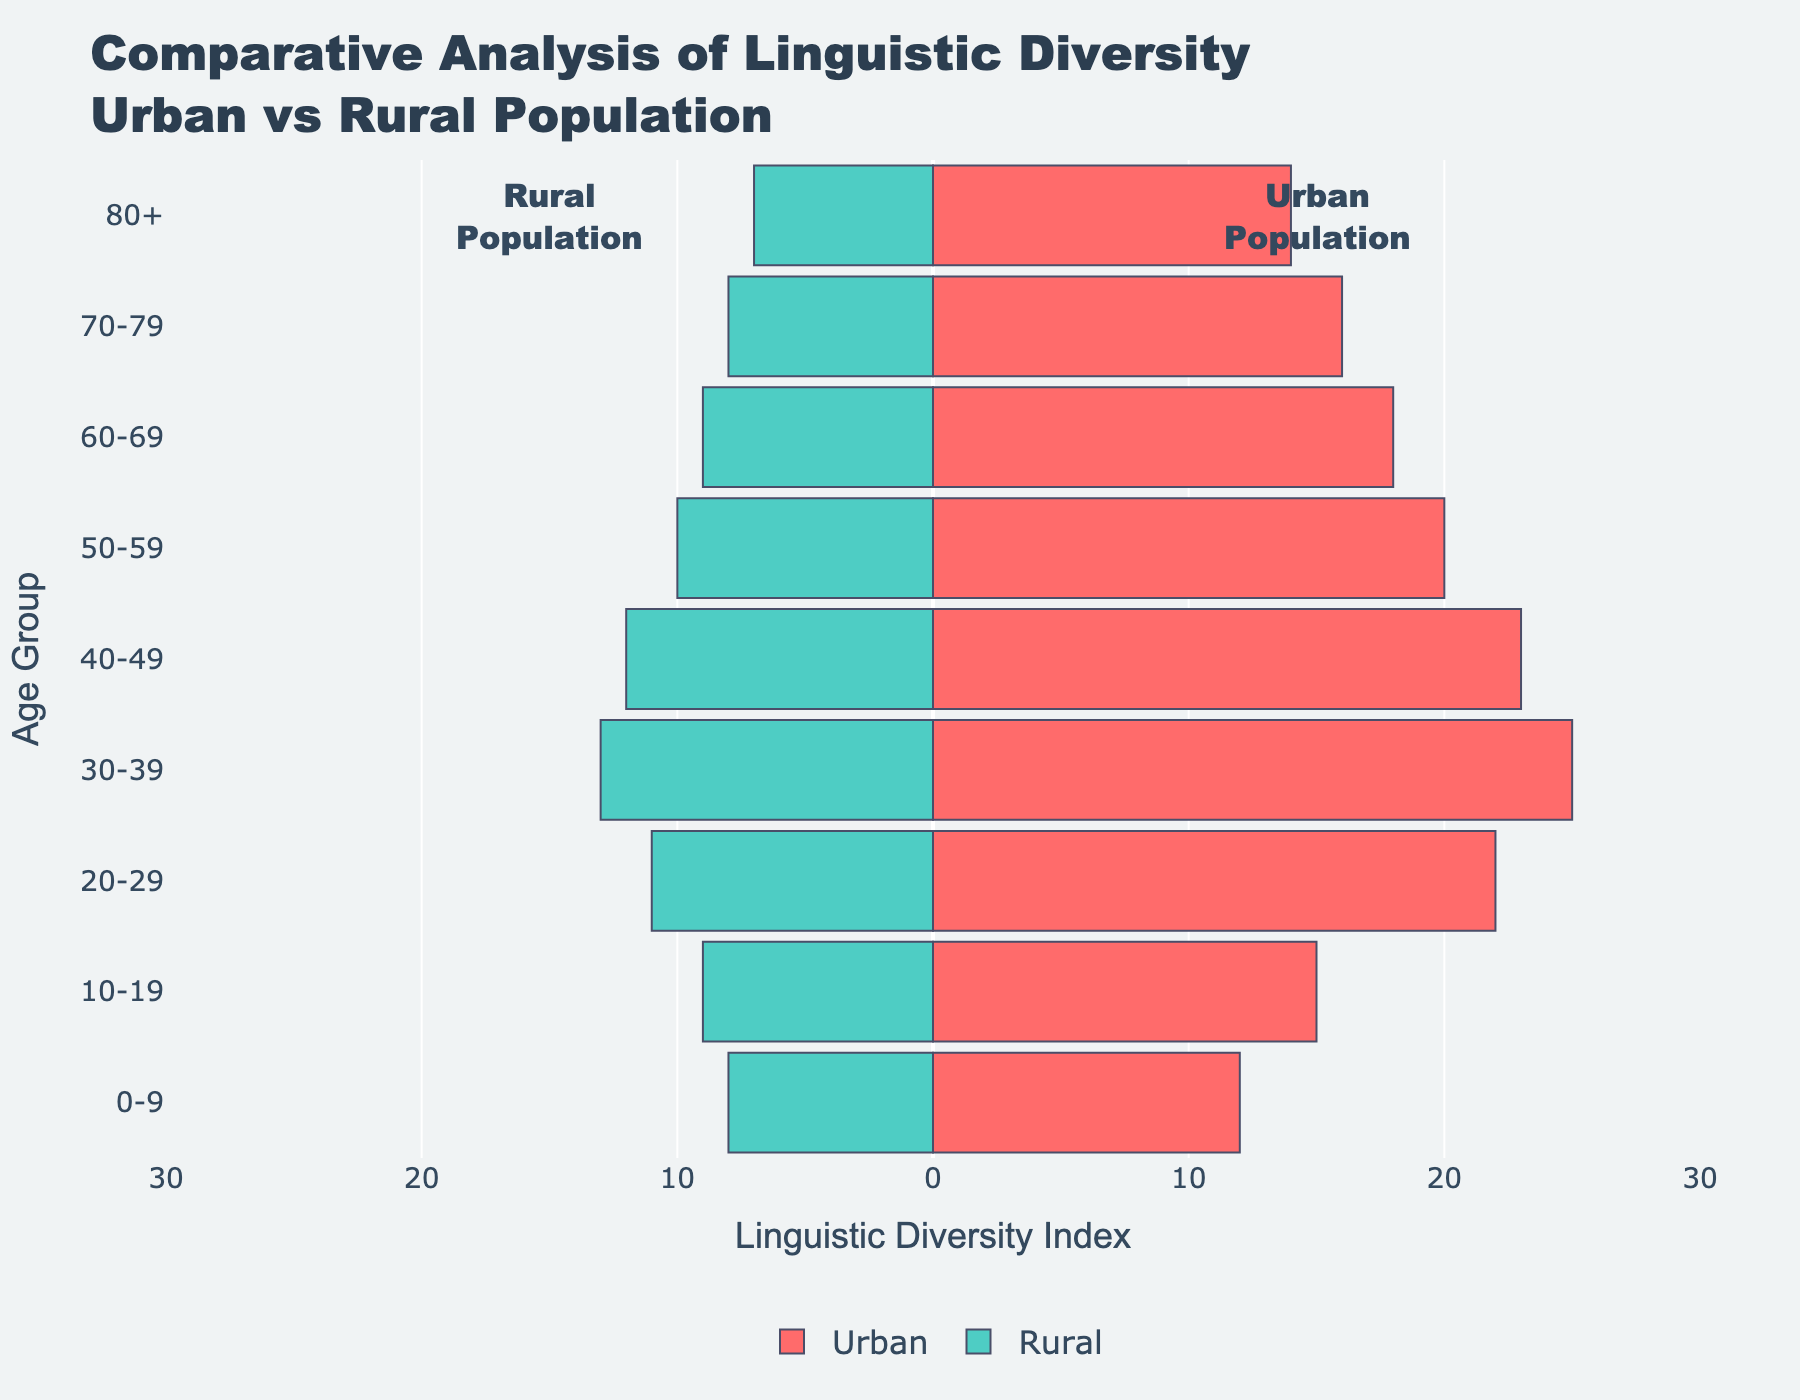What is the title of the figure? The title is located at the top of the figure, it provides an overall summary of what the plot represents. Reading the title gives insight into the content of the figure.
Answer: Comparative Analysis of Linguistic Diversity Urban vs Rural Population Which age group shows the highest linguistic diversity in urban areas? Observing the urban bars of the pyramid, the longest bar indicates the highest linguistic diversity. In this case, it corresponds to the 30-39 age group with the highest urban linguistic diversity.
Answer: 30-39 By how much does urban linguistic diversity in the 40-49 age group exceed that in the rural population? Look at the length of the bars for the 40-49 age group in both urban and rural populations. Urban is 23 and rural is 12. The difference is 23 - 12.
Answer: 11 Which side of the population pyramid represents rural linguistic diversity? The pyramid is asymmetric, with one side representing urban and the other rural. The rural side has negative values.
Answer: Left side What is the average linguistic diversity in urban areas for the 0-9 and 10-19 age groups? Sum the urban linguistic diversity values for 0-9 (12) and 10-19 (15) then divide by 2. (12 + 15) / 2 = 13.5.
Answer: 13.5 How does linguistic diversity change in rural areas from the 20-29 age group to the 60-69 age group? Track the lengths of the bars on the left side for ages 20-29 (11), 30-39 (13), 40-49 (12), 50-59 (10), and 60-69 (9). There is a gradual decline in the values.
Answer: It decreases In which age group is the difference between urban and rural linguistic diversity the smallest? Calculate the difference for each age group and find the smallest: 
0-9: 4, 10-19: 6, 20-29: 11, 30-39: 12, 40-49: 11, 50-59: 10, 60-69: 9, 70-79: 8, 80+: 7. The smallest difference is for the 0-9 age group.
Answer: 0-9 Compare the linguistic diversity index for the urban population in the 50-59 age group and the rural population in the 0-9 age group. Which is higher? Check the value for urban in the 50-59 age group (20) and rural in the 0-9 age group (8). 20 is higher than 8.
Answer: Urban 50-59 What is the total linguistic diversity across all age groups for rural areas? Sum the rural linguistic diversity values: 8, 9, 11, 13, 12, 10, 9, 8, 7.
Total = 77.
Answer: 77 